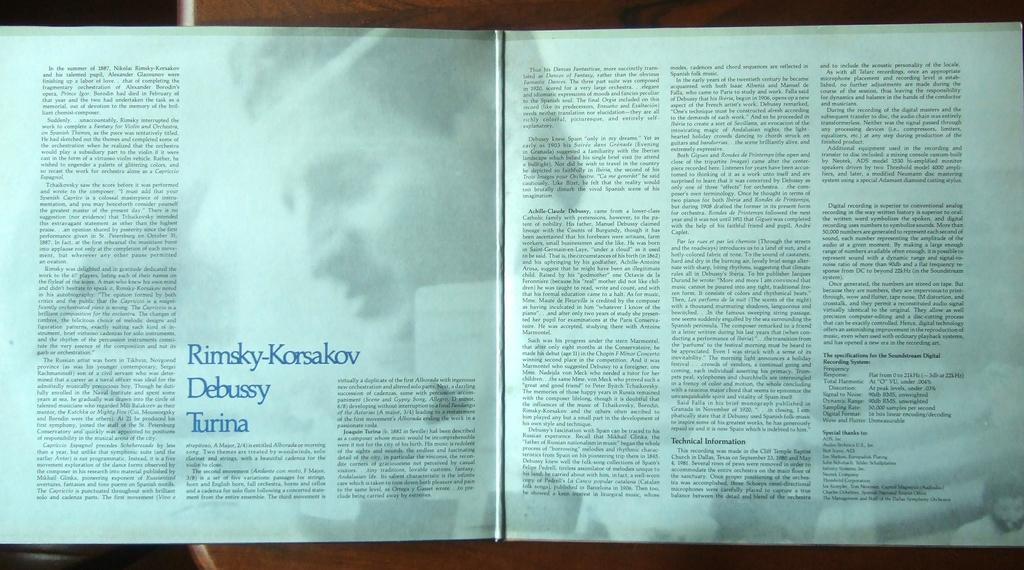Provide a one-sentence caption for the provided image. An open book with the text Rimsky Korsalov Debusy Turina on the middle lower section. 